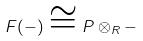<formula> <loc_0><loc_0><loc_500><loc_500>F ( - ) \cong P \otimes _ { R } -</formula> 